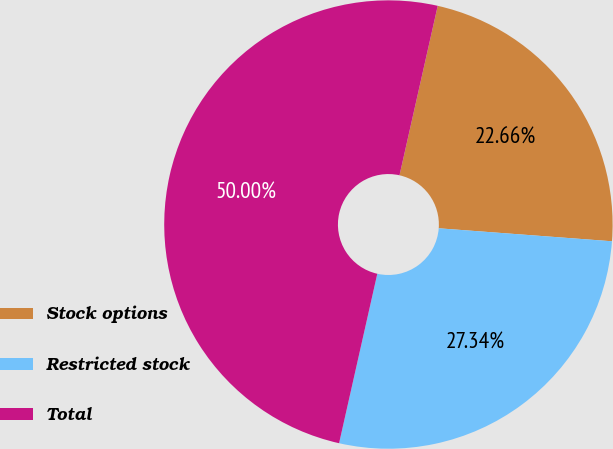<chart> <loc_0><loc_0><loc_500><loc_500><pie_chart><fcel>Stock options<fcel>Restricted stock<fcel>Total<nl><fcel>22.66%<fcel>27.34%<fcel>50.0%<nl></chart> 